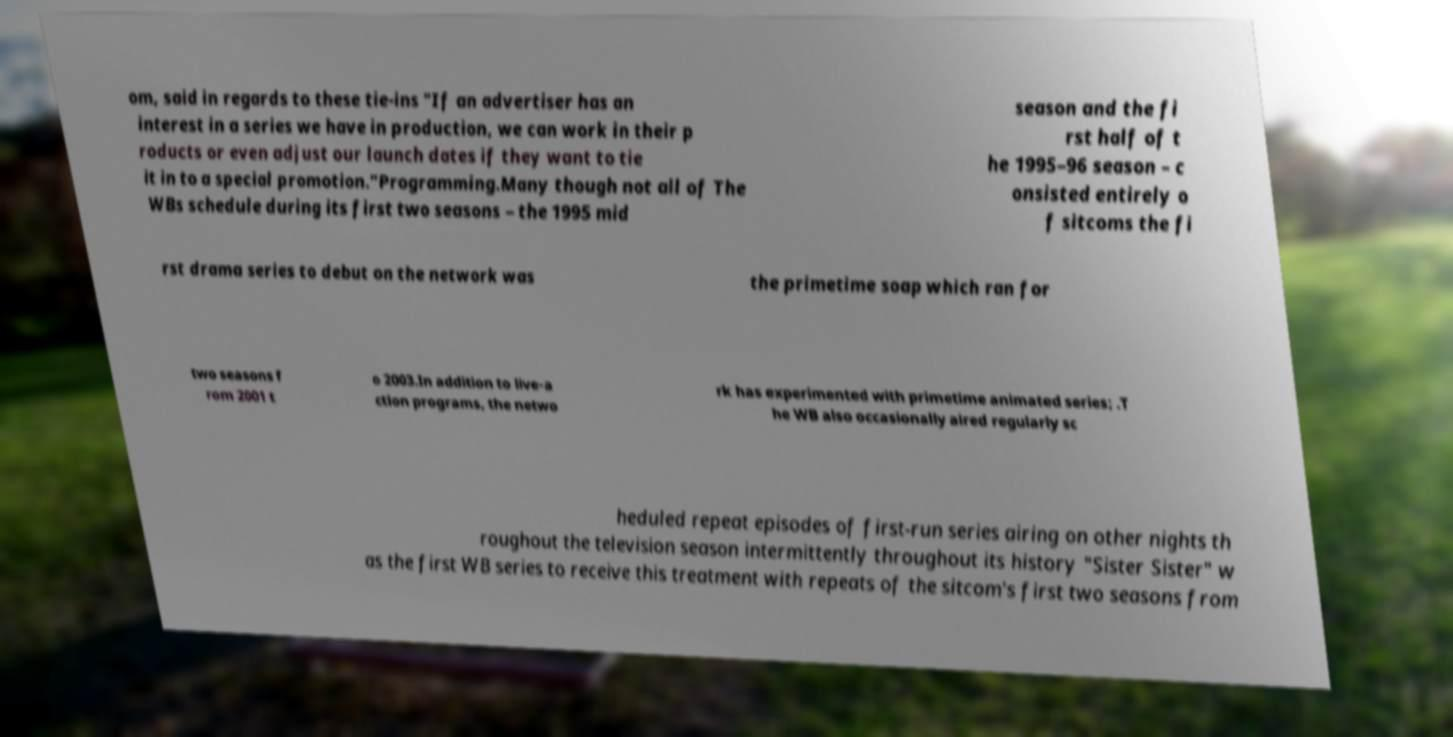Can you accurately transcribe the text from the provided image for me? om, said in regards to these tie-ins "If an advertiser has an interest in a series we have in production, we can work in their p roducts or even adjust our launch dates if they want to tie it in to a special promotion."Programming.Many though not all of The WBs schedule during its first two seasons – the 1995 mid season and the fi rst half of t he 1995–96 season – c onsisted entirely o f sitcoms the fi rst drama series to debut on the network was the primetime soap which ran for two seasons f rom 2001 t o 2003.In addition to live-a ction programs, the netwo rk has experimented with primetime animated series; .T he WB also occasionally aired regularly sc heduled repeat episodes of first-run series airing on other nights th roughout the television season intermittently throughout its history "Sister Sister" w as the first WB series to receive this treatment with repeats of the sitcom's first two seasons from 